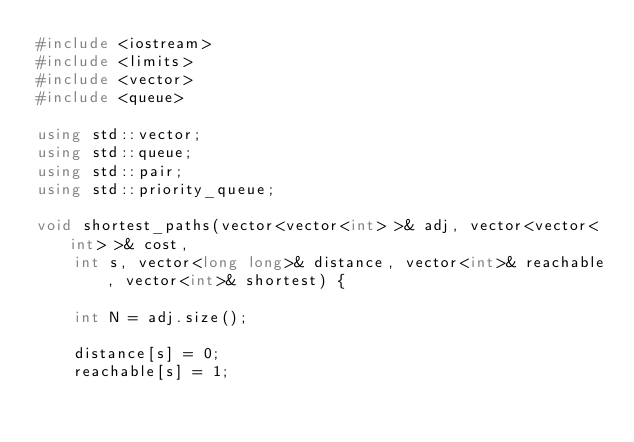Convert code to text. <code><loc_0><loc_0><loc_500><loc_500><_C++_>#include <iostream>
#include <limits>
#include <vector>
#include <queue>

using std::vector;
using std::queue;
using std::pair;
using std::priority_queue;

void shortest_paths(vector<vector<int> >& adj, vector<vector<int> >& cost,
    int s, vector<long long>& distance, vector<int>& reachable, vector<int>& shortest) {

    int N = adj.size();

    distance[s] = 0;
    reachable[s] = 1;
</code> 